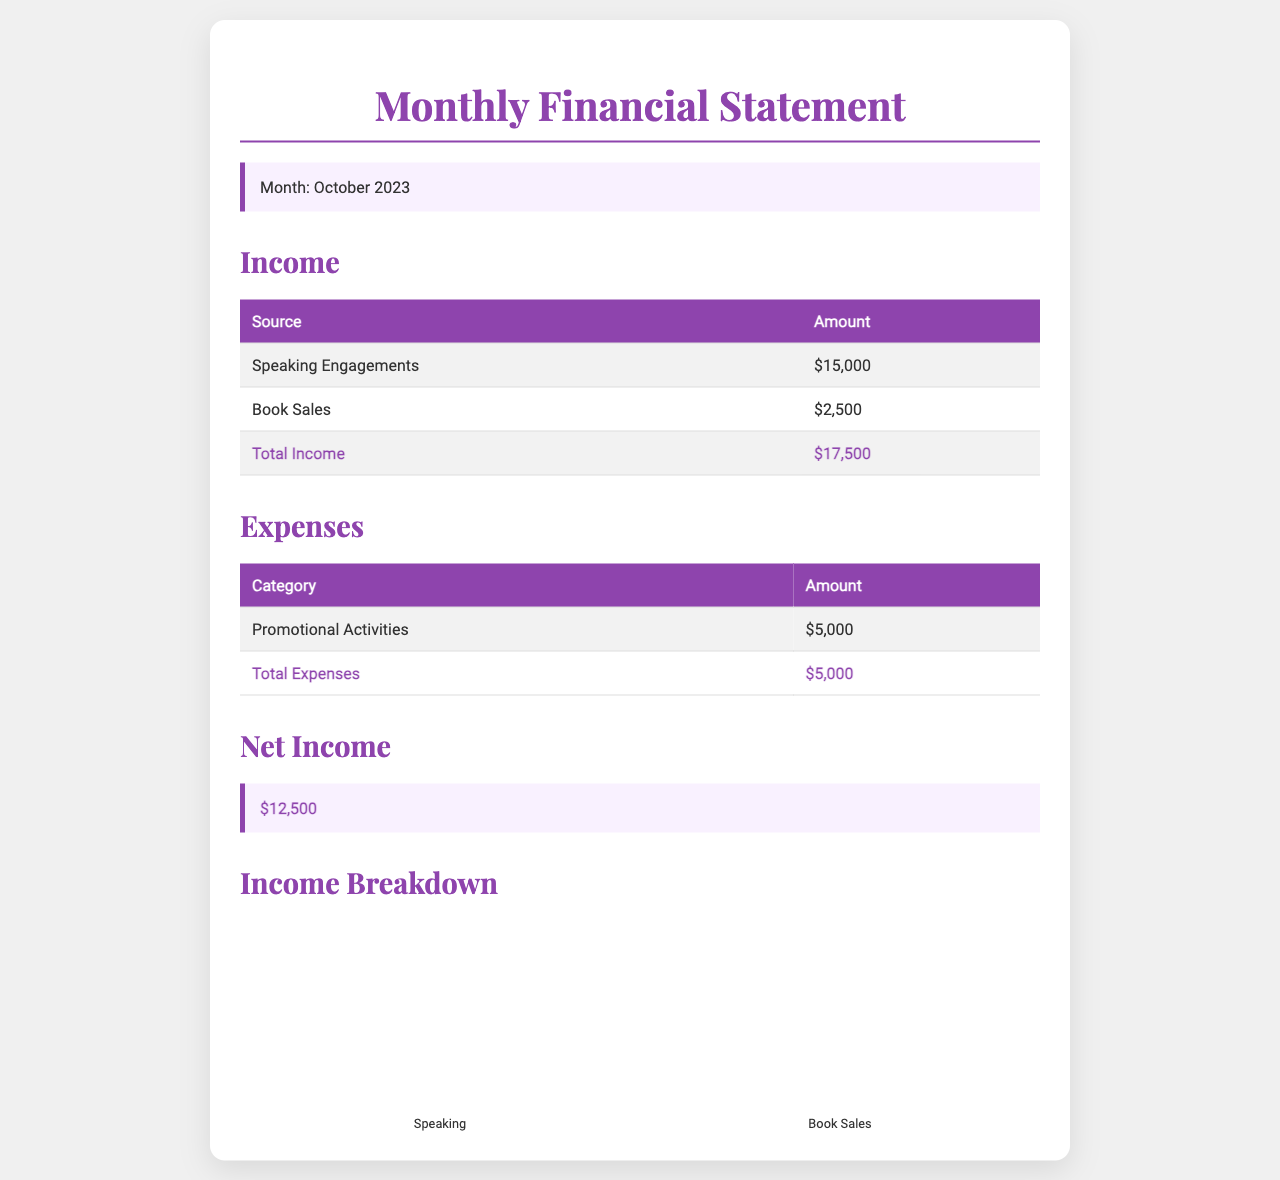What is the total income? The total income is provided as the sum of income from speaking engagements and book sales, which amounts to $15,000 + $2,500.
Answer: $17,500 What were the expenses for the month? The document specifies that the total expenses amounted to $5,000, all attributed to promotional activities.
Answer: $5,000 What is the net income? The net income is calculated by subtracting total expenses from total income, resulting in $17,500 - $5,000.
Answer: $12,500 How much was earned from speaking engagements? The document explicitly states the income from speaking engagements, which is $15,000.
Answer: $15,000 What is the amount from book sales? The income from book sales is provided directly in the table, totaling $2,500.
Answer: $2,500 What category of expenses is detailed in the statement? The only expense category mentioned in the document is promotional activities.
Answer: Promotional Activities What was the primary source of income? The primary source of income is listed as speaking engagements, contributing the most to the total income.
Answer: Speaking Engagements What percentage of total income came from book sales? The income from book sales ($2,500) is a portion of the total income ($17,500); the percentage is calculated as (2,500 / 17,500) * 100.
Answer: 14.29% What color is the heading for the expenses section? The heading for the expenses section, like other headings in the document, is in a specific color; the color used for headings is indicated as #8e44ad.
Answer: #8e44ad 